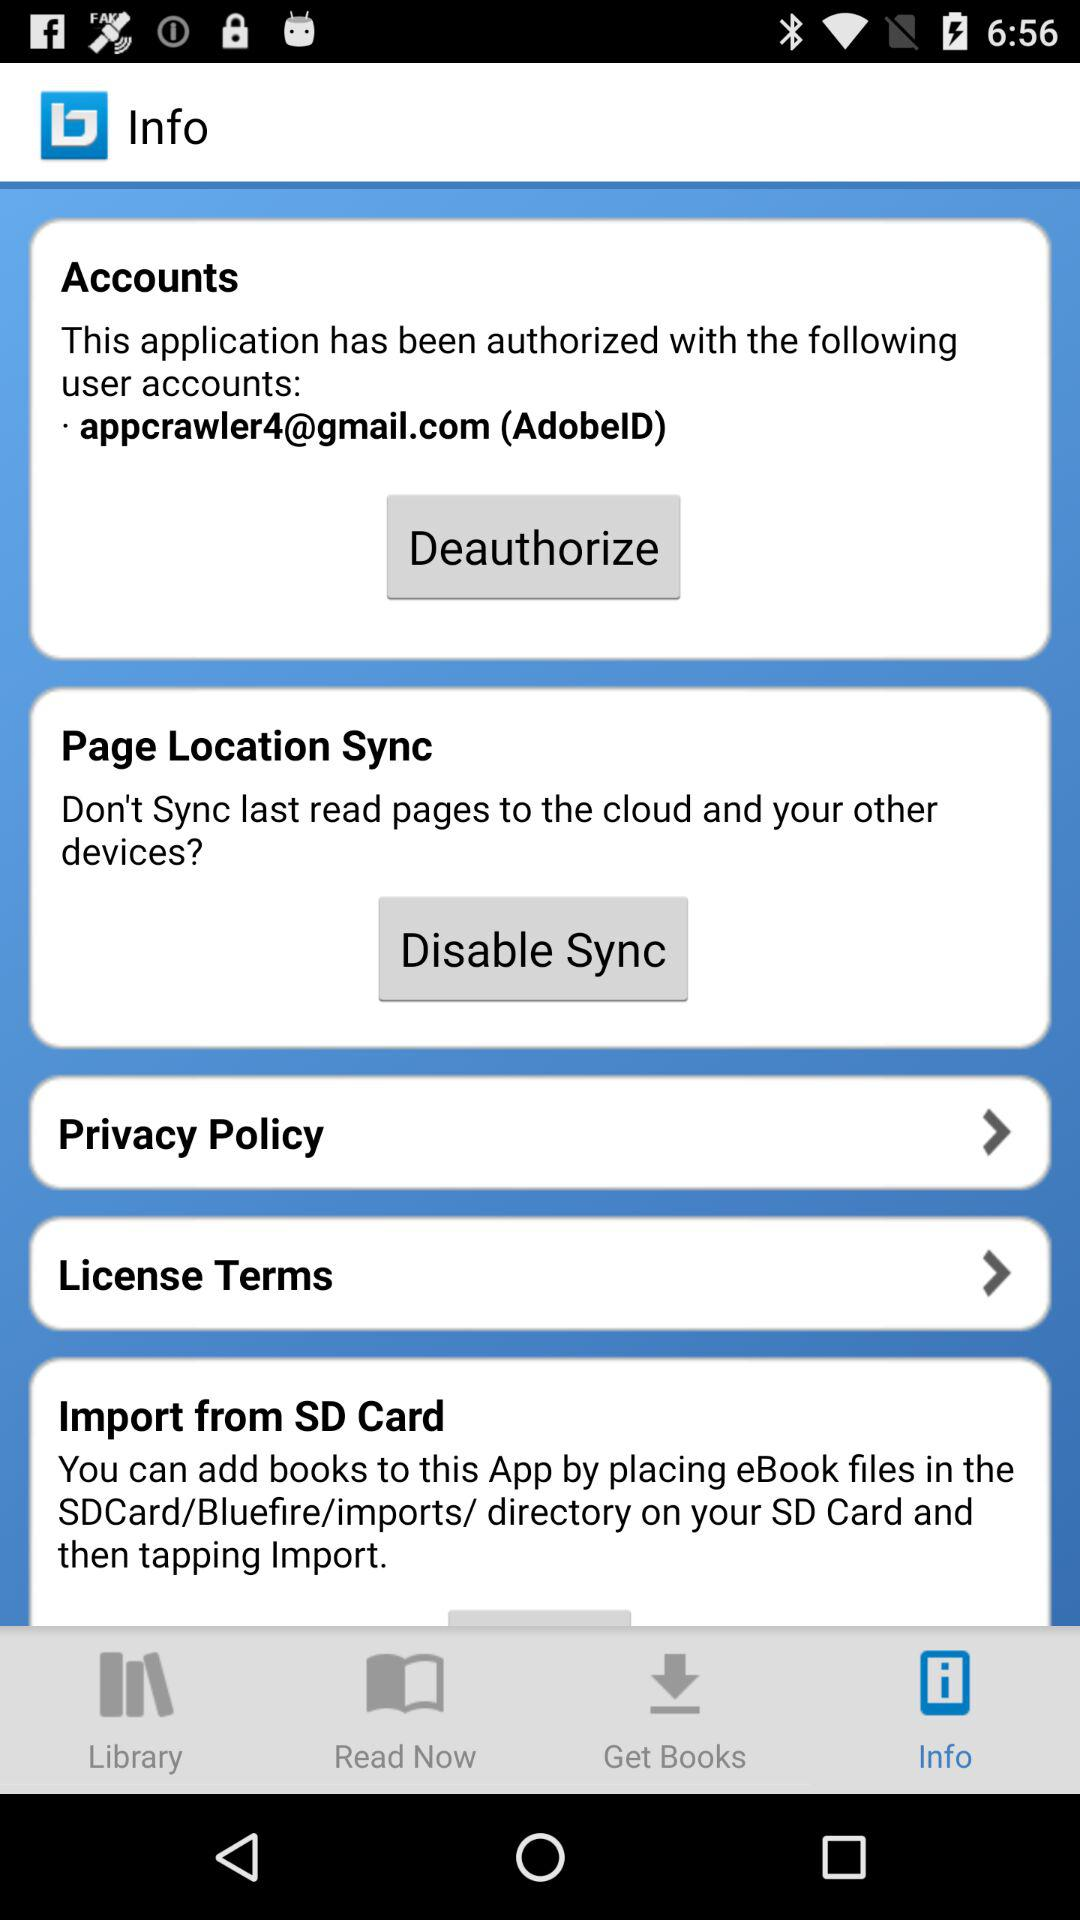What is the email address? The email address is appcrawler4@gmail.com. 